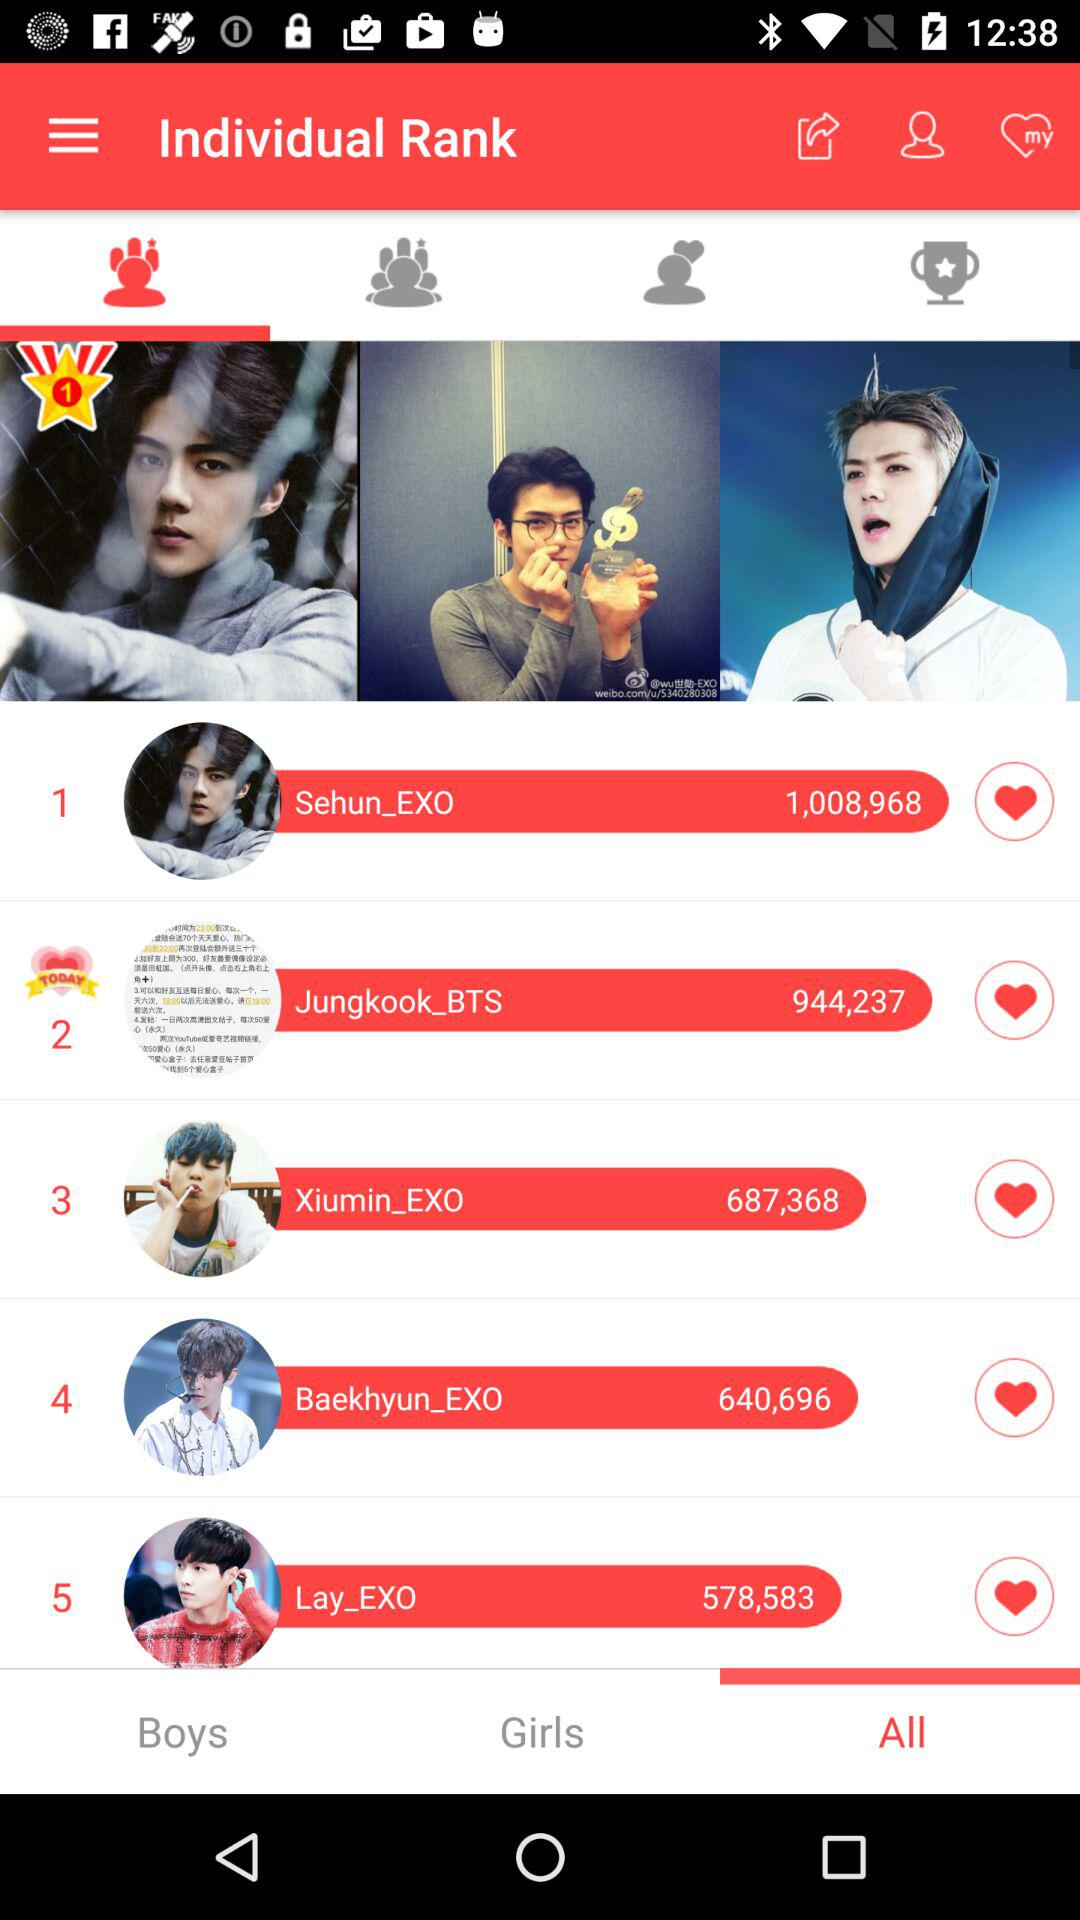How many points did Sehun_EXO get? Sehun_EXO got 1,008,968 points. 